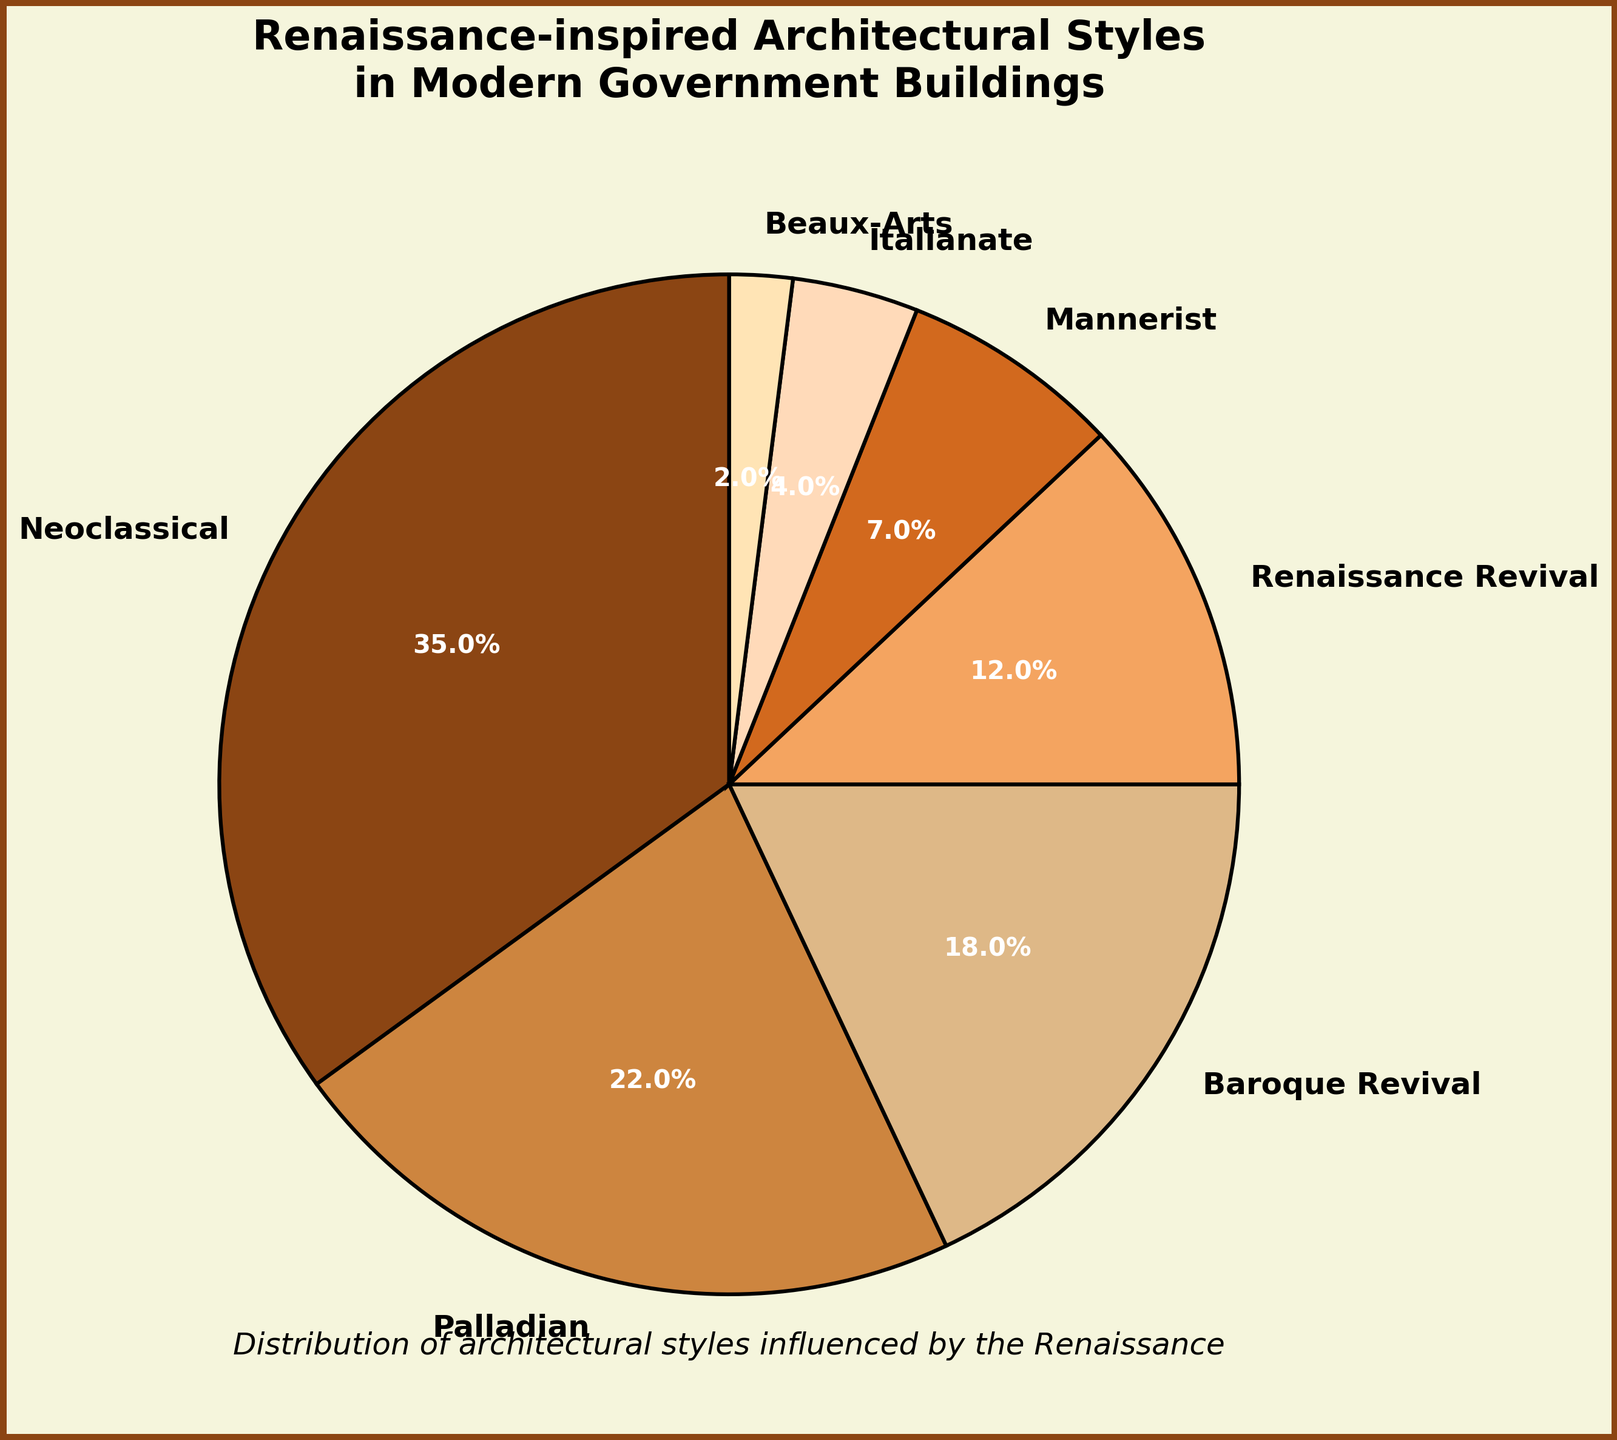What percentage of modern government buildings feature a combination of the three most popular Renaissance-inspired styles? Identify the three most significant pie sections labeled as Neoclassical (35%), Palladian (22%), and Baroque Revival (18%). Sum these values: 35% + 22% + 18% = 75%.
Answer: 75% Which style has a higher percentage: Baroque Revival or Renaissance Revival? Compare the percentages given for Baroque Revival (18%) and Renaissance Revival (12%). Baroque Revival is higher.
Answer: Baroque Revival What is the percentage difference between the least and the most common Renaissance-inspired architectural styles? Identify the least common style, which is Beaux-Arts at 2%, and the most common style, which is Neoclassical at 35%. Calculate the difference: 35% - 2% = 33%.
Answer: 33% What is the combined percentage of styles that have less than 10% representation? Identify styles with less than 10%: Mannerist (7%), Italianate (4%), and Beaux-Arts (2%). Sum these percentages: 7% + 4% + 2% = 13%.
Answer: 13% Which style shares the closest percentage to one-third of the total pie chart? One-third of the pie chart is approximately 33.3%. Compare this value to the given percentages: Neoclassical (35%) is the closest.
Answer: Neoclassical Which segment is represented by light brown color? Visually identify the segment with light brown color. According to the provided colors, Palladian is represented by light brown color (or the second applicable from the custom color palette).
Answer: Palladian How many styles have a representation of over 20%? Inspect the pie chart to see which styles exceed 20% representation: Neoclassical (35%) and Palladian (22%). These are two styles.
Answer: 2 If the styles were grouped into two parts, one with over 15% representation and one with less than 15%, what would be the percentage of the latter group? Identify styles with over 15%: Neoclassical (35%), Palladian (22%), Baroque Revival (18%). Calculate the sum of the latter: Renaissance Revival (12%) + Mannerist (7%) + Italianate (4%) + Beaux-Arts (2%) = 25%.
Answer: 25% Which style is represented by the smallest segment? Observe the pie chart to find the smallest segment. The smallest percentage is 2%, which corresponds to Beaux-Arts.
Answer: Beaux-Arts Is the combined percentage of Renaissance Revival and Baroque Revival greater than half of the total pie chart? Sum the percentages: Renaissance Revival (12%) + Baroque Revival (18%) = 30%. Since 30% is less than 50%, it is not greater.
Answer: No 